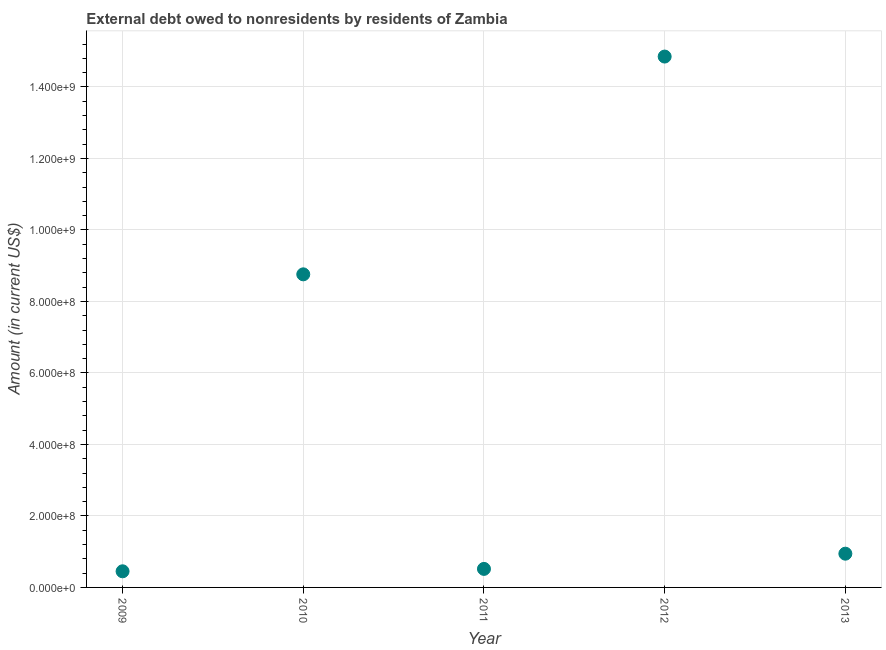What is the debt in 2011?
Ensure brevity in your answer.  5.18e+07. Across all years, what is the maximum debt?
Make the answer very short. 1.49e+09. Across all years, what is the minimum debt?
Provide a succinct answer. 4.51e+07. In which year was the debt maximum?
Ensure brevity in your answer.  2012. What is the sum of the debt?
Provide a short and direct response. 2.55e+09. What is the difference between the debt in 2010 and 2012?
Provide a short and direct response. -6.09e+08. What is the average debt per year?
Make the answer very short. 5.10e+08. What is the median debt?
Keep it short and to the point. 9.44e+07. Do a majority of the years between 2012 and 2011 (inclusive) have debt greater than 960000000 US$?
Your response must be concise. No. What is the ratio of the debt in 2010 to that in 2013?
Ensure brevity in your answer.  9.28. Is the debt in 2009 less than that in 2012?
Give a very brief answer. Yes. Is the difference between the debt in 2009 and 2010 greater than the difference between any two years?
Your answer should be very brief. No. What is the difference between the highest and the second highest debt?
Your answer should be very brief. 6.09e+08. What is the difference between the highest and the lowest debt?
Offer a terse response. 1.44e+09. Does the debt monotonically increase over the years?
Your answer should be compact. No. How many years are there in the graph?
Offer a very short reply. 5. What is the difference between two consecutive major ticks on the Y-axis?
Keep it short and to the point. 2.00e+08. Are the values on the major ticks of Y-axis written in scientific E-notation?
Your answer should be compact. Yes. What is the title of the graph?
Your answer should be compact. External debt owed to nonresidents by residents of Zambia. What is the label or title of the X-axis?
Provide a succinct answer. Year. What is the Amount (in current US$) in 2009?
Keep it short and to the point. 4.51e+07. What is the Amount (in current US$) in 2010?
Offer a terse response. 8.76e+08. What is the Amount (in current US$) in 2011?
Your answer should be very brief. 5.18e+07. What is the Amount (in current US$) in 2012?
Give a very brief answer. 1.49e+09. What is the Amount (in current US$) in 2013?
Offer a very short reply. 9.44e+07. What is the difference between the Amount (in current US$) in 2009 and 2010?
Keep it short and to the point. -8.31e+08. What is the difference between the Amount (in current US$) in 2009 and 2011?
Your answer should be compact. -6.71e+06. What is the difference between the Amount (in current US$) in 2009 and 2012?
Provide a short and direct response. -1.44e+09. What is the difference between the Amount (in current US$) in 2009 and 2013?
Give a very brief answer. -4.93e+07. What is the difference between the Amount (in current US$) in 2010 and 2011?
Your answer should be very brief. 8.24e+08. What is the difference between the Amount (in current US$) in 2010 and 2012?
Keep it short and to the point. -6.09e+08. What is the difference between the Amount (in current US$) in 2010 and 2013?
Ensure brevity in your answer.  7.81e+08. What is the difference between the Amount (in current US$) in 2011 and 2012?
Offer a very short reply. -1.43e+09. What is the difference between the Amount (in current US$) in 2011 and 2013?
Keep it short and to the point. -4.26e+07. What is the difference between the Amount (in current US$) in 2012 and 2013?
Keep it short and to the point. 1.39e+09. What is the ratio of the Amount (in current US$) in 2009 to that in 2010?
Offer a very short reply. 0.05. What is the ratio of the Amount (in current US$) in 2009 to that in 2011?
Provide a short and direct response. 0.87. What is the ratio of the Amount (in current US$) in 2009 to that in 2012?
Offer a terse response. 0.03. What is the ratio of the Amount (in current US$) in 2009 to that in 2013?
Your response must be concise. 0.48. What is the ratio of the Amount (in current US$) in 2010 to that in 2011?
Offer a very short reply. 16.9. What is the ratio of the Amount (in current US$) in 2010 to that in 2012?
Your response must be concise. 0.59. What is the ratio of the Amount (in current US$) in 2010 to that in 2013?
Make the answer very short. 9.28. What is the ratio of the Amount (in current US$) in 2011 to that in 2012?
Provide a short and direct response. 0.04. What is the ratio of the Amount (in current US$) in 2011 to that in 2013?
Offer a very short reply. 0.55. What is the ratio of the Amount (in current US$) in 2012 to that in 2013?
Provide a succinct answer. 15.73. 